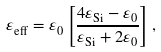Convert formula to latex. <formula><loc_0><loc_0><loc_500><loc_500>\varepsilon _ { \text {eff} } = \varepsilon _ { 0 } \left [ \frac { 4 \varepsilon _ { \text {Si} } - \varepsilon _ { 0 } } { \varepsilon _ { \text {Si} } + 2 \varepsilon _ { 0 } } \right ] ,</formula> 